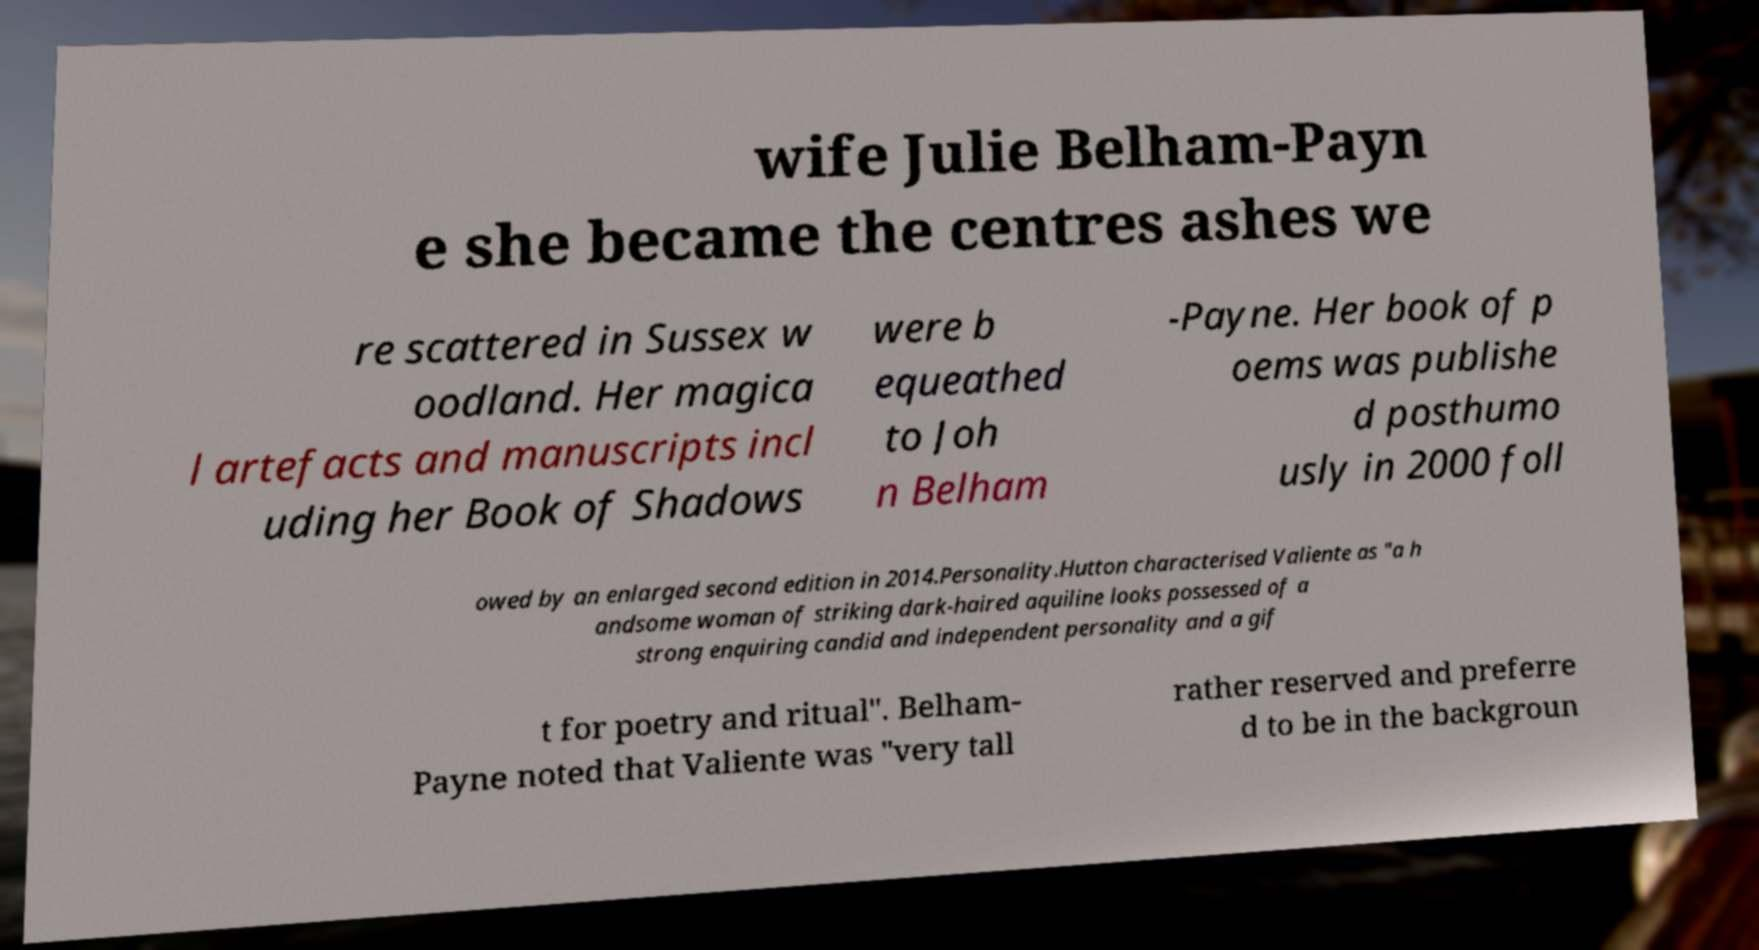I need the written content from this picture converted into text. Can you do that? wife Julie Belham-Payn e she became the centres ashes we re scattered in Sussex w oodland. Her magica l artefacts and manuscripts incl uding her Book of Shadows were b equeathed to Joh n Belham -Payne. Her book of p oems was publishe d posthumo usly in 2000 foll owed by an enlarged second edition in 2014.Personality.Hutton characterised Valiente as "a h andsome woman of striking dark-haired aquiline looks possessed of a strong enquiring candid and independent personality and a gif t for poetry and ritual". Belham- Payne noted that Valiente was "very tall rather reserved and preferre d to be in the backgroun 